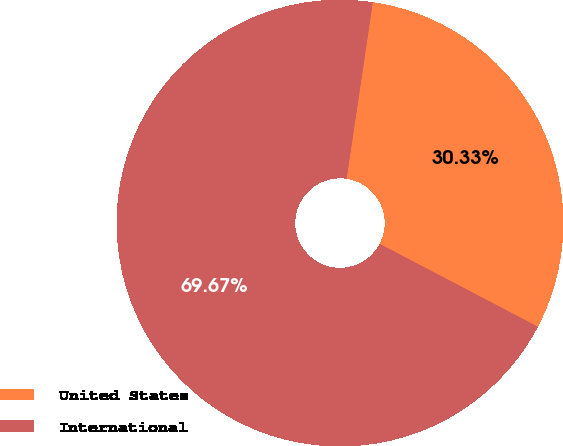<chart> <loc_0><loc_0><loc_500><loc_500><pie_chart><fcel>United States<fcel>International<nl><fcel>30.33%<fcel>69.67%<nl></chart> 